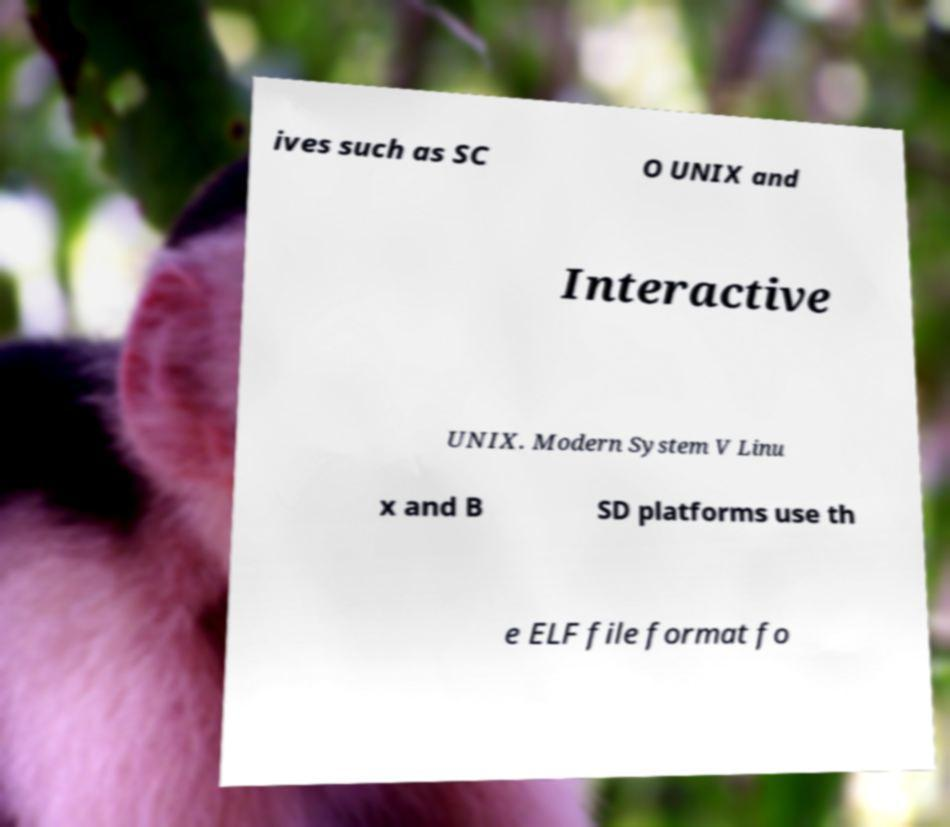Please identify and transcribe the text found in this image. ives such as SC O UNIX and Interactive UNIX. Modern System V Linu x and B SD platforms use th e ELF file format fo 